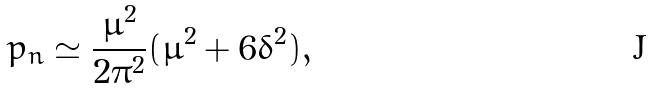Convert formula to latex. <formula><loc_0><loc_0><loc_500><loc_500>p _ { n } \simeq \frac { \bar { \mu } ^ { 2 } } { 2 \pi ^ { 2 } } ( \bar { \mu } ^ { 2 } + 6 \delta ^ { 2 } ) ,</formula> 